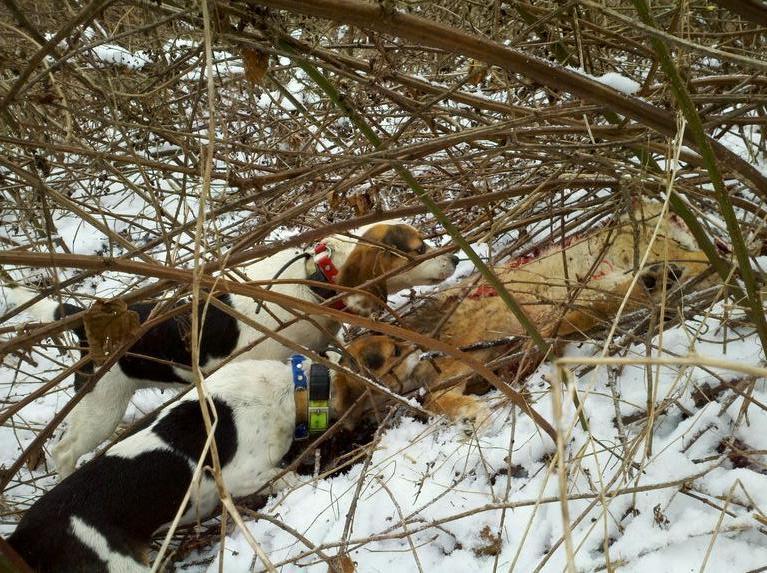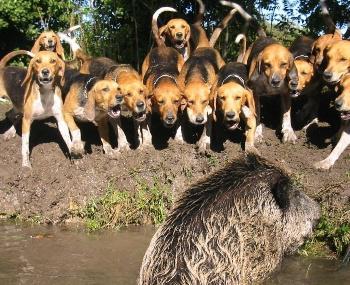The first image is the image on the left, the second image is the image on the right. Evaluate the accuracy of this statement regarding the images: "All images include a beagle in an outdoor setting, and at least one image shows multiple beagles behind a prey animal.". Is it true? Answer yes or no. Yes. The first image is the image on the left, the second image is the image on the right. Considering the images on both sides, is "One dog is standing at attention and facing left." valid? Answer yes or no. No. 